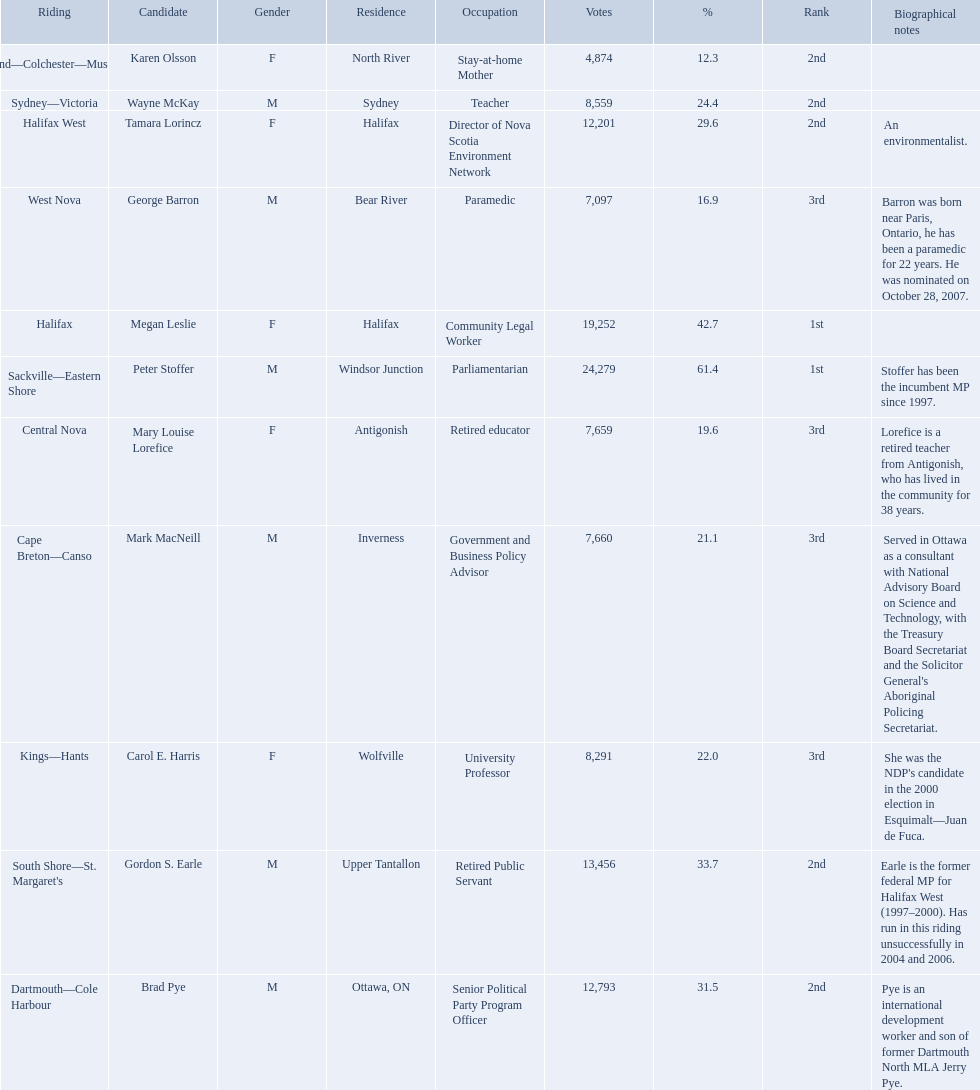How many votes did macneill receive? 7,660. How many votes did olsoon receive? 4,874. Between macneil and olsson, who received more votes? Mark MacNeill. Who were the new democratic party candidates, 2008? Mark MacNeill, Mary Louise Lorefice, Karen Olsson, Brad Pye, Megan Leslie, Tamara Lorincz, Carol E. Harris, Peter Stoffer, Gordon S. Earle, Wayne McKay, George Barron. Who had the 2nd highest number of votes? Megan Leslie, Peter Stoffer. How many votes did she receive? 19,252. 